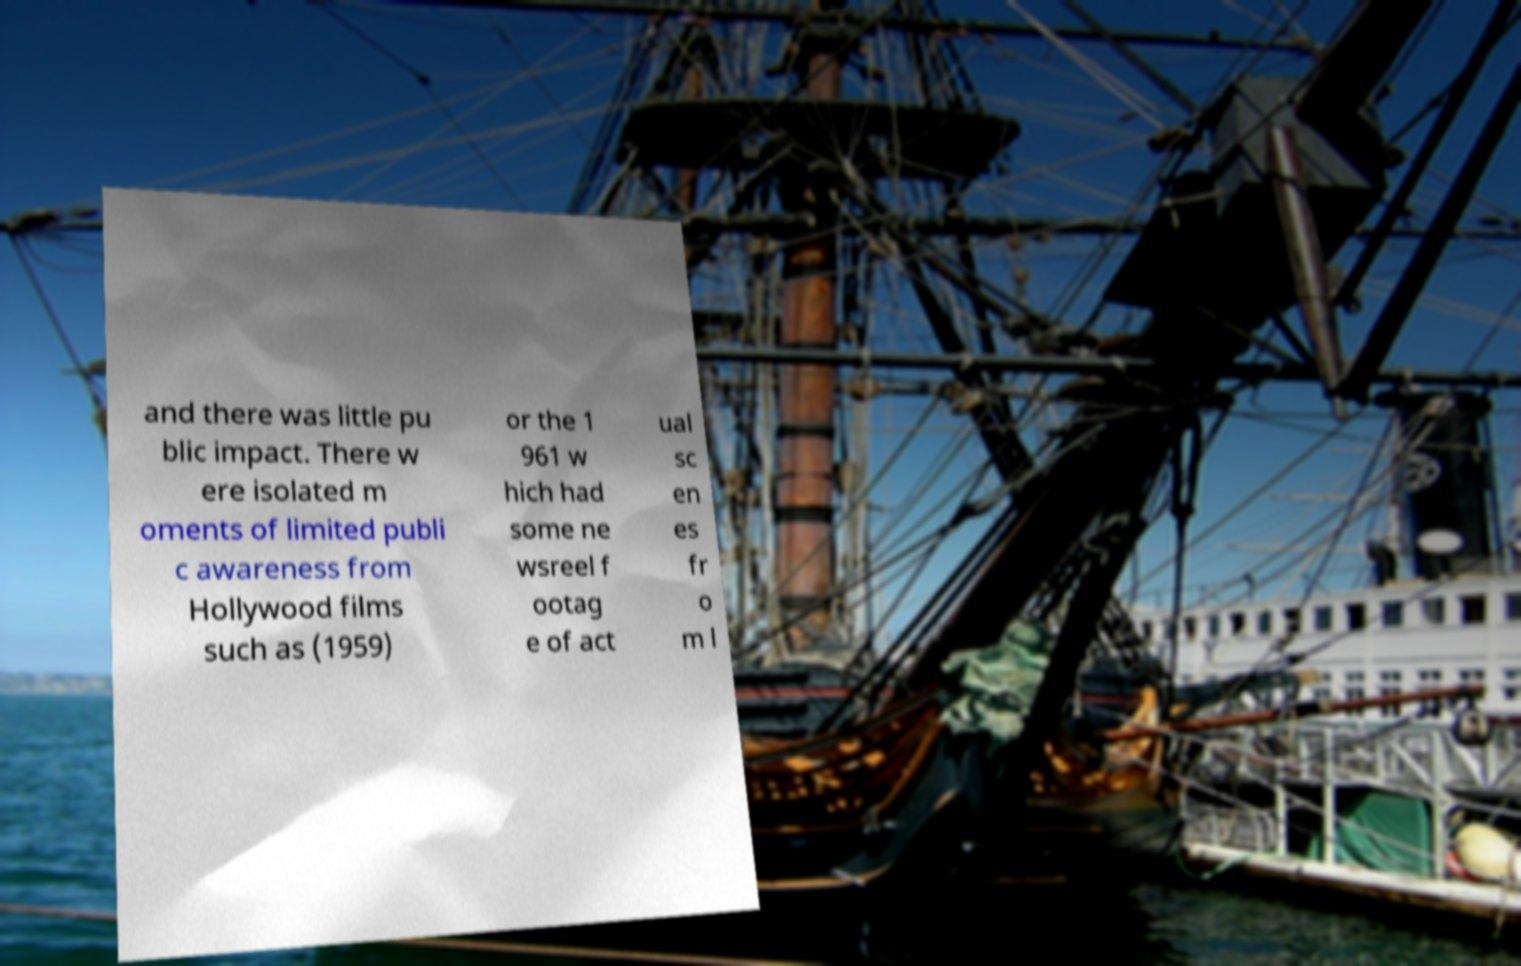Can you read and provide the text displayed in the image?This photo seems to have some interesting text. Can you extract and type it out for me? and there was little pu blic impact. There w ere isolated m oments of limited publi c awareness from Hollywood films such as (1959) or the 1 961 w hich had some ne wsreel f ootag e of act ual sc en es fr o m l 